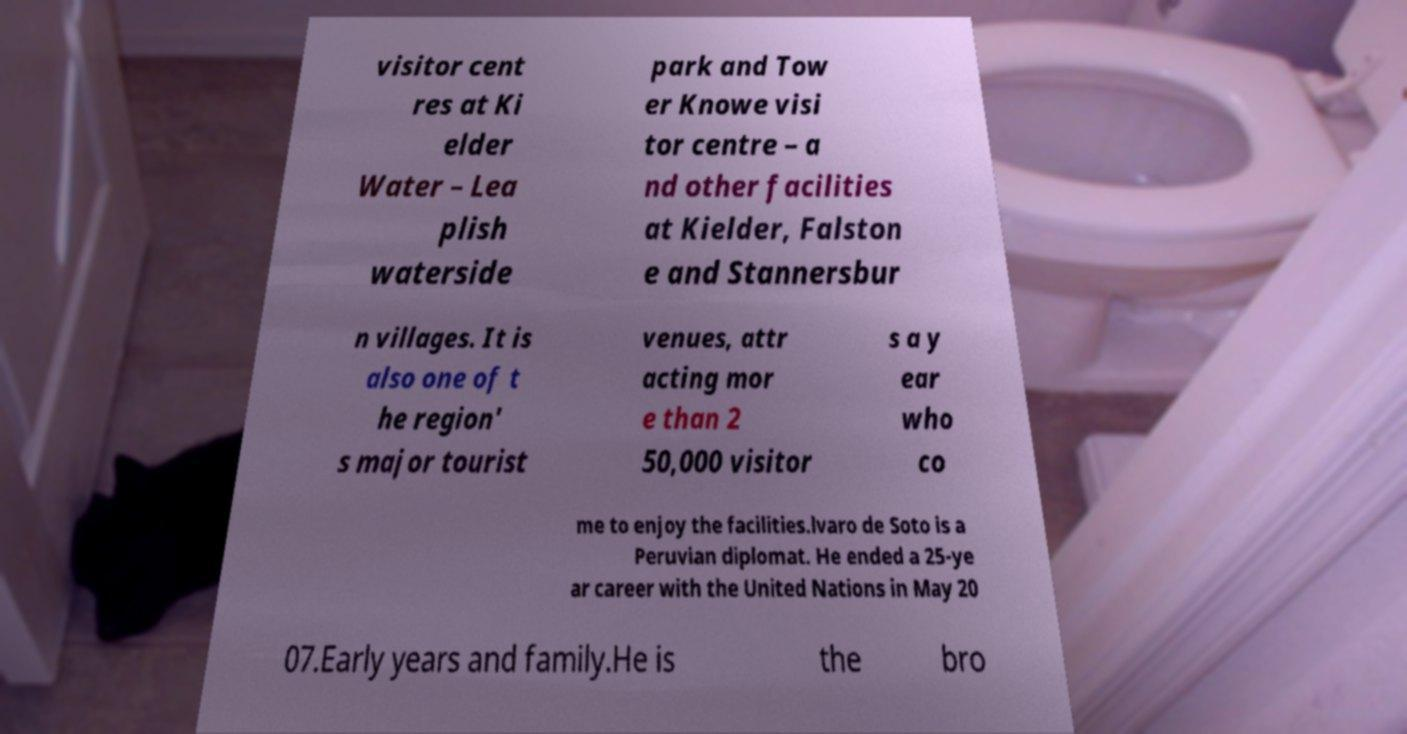There's text embedded in this image that I need extracted. Can you transcribe it verbatim? visitor cent res at Ki elder Water – Lea plish waterside park and Tow er Knowe visi tor centre – a nd other facilities at Kielder, Falston e and Stannersbur n villages. It is also one of t he region' s major tourist venues, attr acting mor e than 2 50,000 visitor s a y ear who co me to enjoy the facilities.lvaro de Soto is a Peruvian diplomat. He ended a 25-ye ar career with the United Nations in May 20 07.Early years and family.He is the bro 